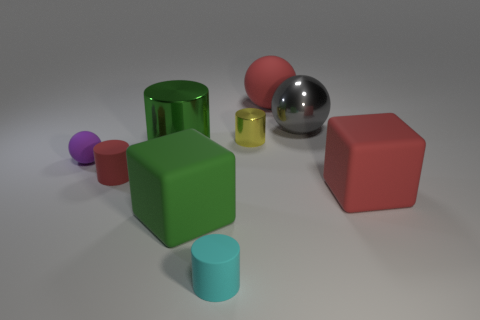Subtract all green cylinders. Subtract all green blocks. How many cylinders are left? 3 Add 1 tiny red shiny things. How many objects exist? 10 Subtract all cubes. How many objects are left? 7 Subtract all green cylinders. Subtract all big purple objects. How many objects are left? 8 Add 4 gray metallic spheres. How many gray metallic spheres are left? 5 Add 9 big cylinders. How many big cylinders exist? 10 Subtract 0 green spheres. How many objects are left? 9 